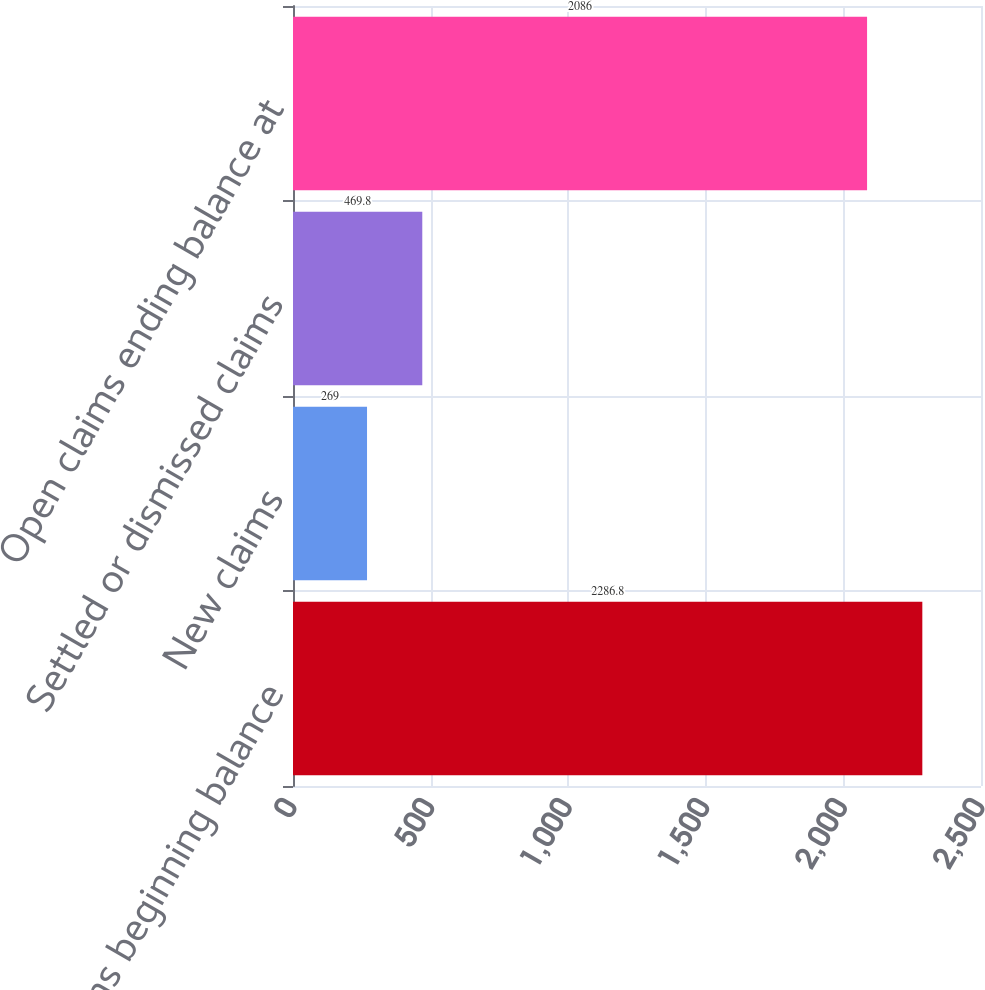<chart> <loc_0><loc_0><loc_500><loc_500><bar_chart><fcel>Open claims beginning balance<fcel>New claims<fcel>Settled or dismissed claims<fcel>Open claims ending balance at<nl><fcel>2286.8<fcel>269<fcel>469.8<fcel>2086<nl></chart> 